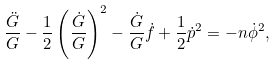Convert formula to latex. <formula><loc_0><loc_0><loc_500><loc_500>\frac { \ddot { G } } { G } - \frac { 1 } { 2 } \left ( \frac { \dot { G } } { G } \right ) ^ { 2 } - \frac { \dot { G } } { G } \dot { f } + \frac { 1 } { 2 } \dot { p } ^ { 2 } = - n \dot { \phi } ^ { 2 } ,</formula> 